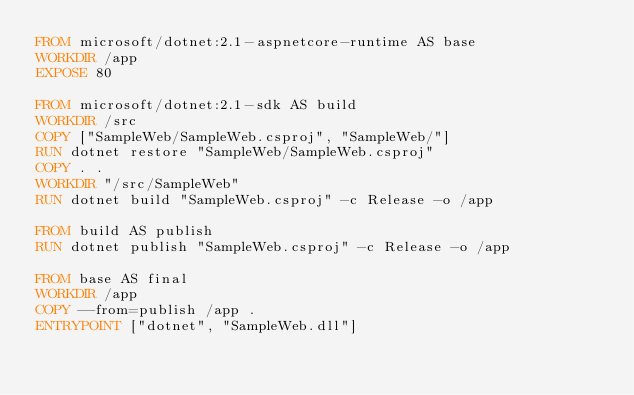Convert code to text. <code><loc_0><loc_0><loc_500><loc_500><_Dockerfile_>FROM microsoft/dotnet:2.1-aspnetcore-runtime AS base
WORKDIR /app
EXPOSE 80

FROM microsoft/dotnet:2.1-sdk AS build
WORKDIR /src
COPY ["SampleWeb/SampleWeb.csproj", "SampleWeb/"]
RUN dotnet restore "SampleWeb/SampleWeb.csproj"
COPY . .
WORKDIR "/src/SampleWeb"
RUN dotnet build "SampleWeb.csproj" -c Release -o /app

FROM build AS publish
RUN dotnet publish "SampleWeb.csproj" -c Release -o /app

FROM base AS final
WORKDIR /app
COPY --from=publish /app .
ENTRYPOINT ["dotnet", "SampleWeb.dll"]
</code> 